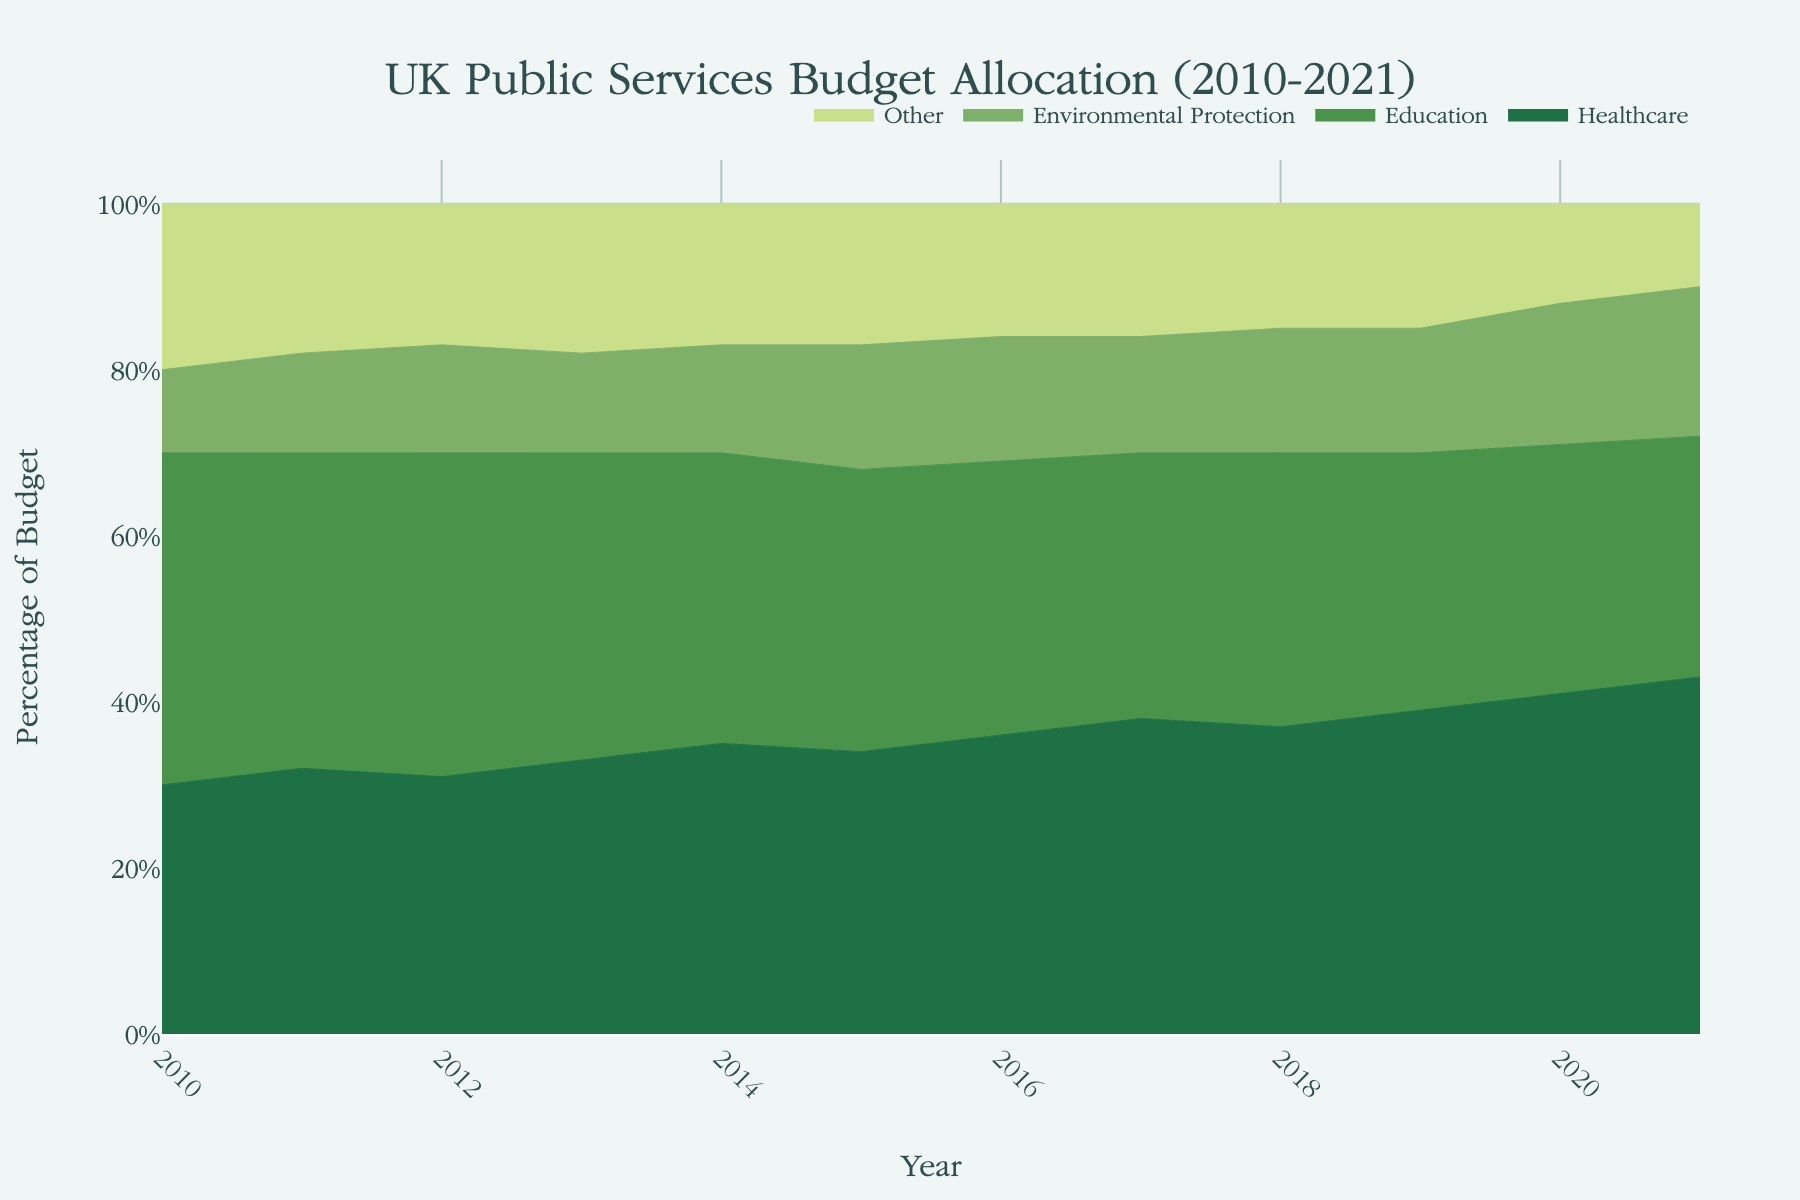What is the title of the chart? The title is located at the top center of the chart and describes the main topic.
Answer: UK Public Services Budget Allocation (2010-2021) Which public service increased the most in percentage from 2010 to 2021? By examining the endpoints of each area in the chart from 2010 to 2021, the height increase of the 'Healthcare' service is notable. The healthcare percentage increased from 30% in 2010 to 43% in 2021.
Answer: Healthcare In which year did environmental protection see the highest percentage allocation? Look for the year with the highest segment size for 'Environmental Protection'. The chart shows the highest allocation in 2021.
Answer: 2021 How did the percentage allocated to education in 2020 compare to that in 2011? Identify the percentages for education in both years. In 2020, the allocation is 30%, while in 2011 it's 38%. Calculate the difference which shows a decrease of 8 percentage points.
Answer: Decreased by 8 percentage points What was the percentage allocated to 'Other' in 2015? The 'Other' category is calculated by subtracting the sum of healthcare, education, and environmental protection in 2015 from 100%. From the data: 100% - (34% + 34% + 15%) = 17%.
Answer: 17% Between which consecutive years does healthcare see the biggest jump in its allocation percentage? By comparing year-to-year changes, the biggest increase in healthcare allocation is noticed between 2019 and 2020, where it jumps from 39% to 41%.
Answer: Between 2019 and 2020 What is the general trend in budget allocation for education from 2010 to 2021? Observing the area representing education over the years, the trend shows a general decline from 40% in 2010 to 29% in 2021.
Answer: Declining trend What was the total percentage allocated to healthcare and environmental protection in 2018? Sum the percentages of healthcare and environmental protection for 2018: 37% + 15% = 52%.
Answer: 52% Which public service's budget allocation remained relatively stable throughout the years? The 'Environmental Protection' allocation shows slight variations but remains relatively closer compared to others. It starts at 10% in 2010 and ends at 18% in 2021 with minor fluctuations in between.
Answer: Environmental Protection What can be inferred about the UK's emphasis on healthcare over the years? The continuous increase in healthcare's budget allocation from 30% in 2010 to 43% in 2021 suggests a growing emphasis.
Answer: Growing emphasis on healthcare 